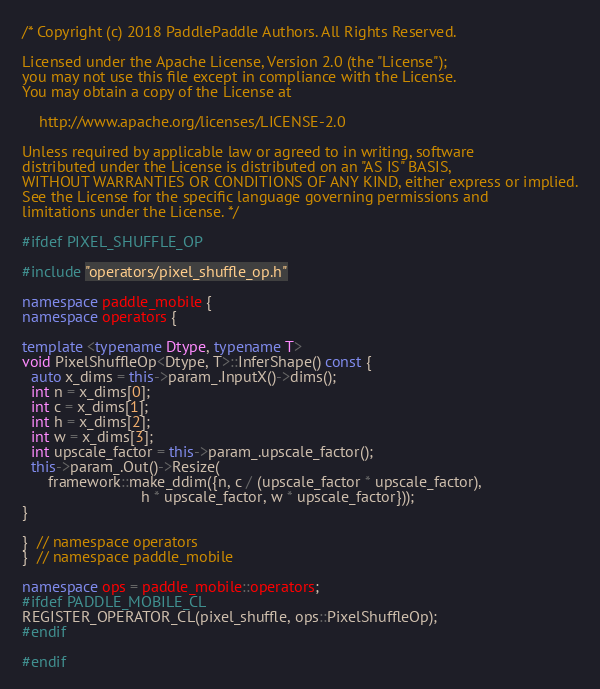Convert code to text. <code><loc_0><loc_0><loc_500><loc_500><_C++_>/* Copyright (c) 2018 PaddlePaddle Authors. All Rights Reserved.

Licensed under the Apache License, Version 2.0 (the "License");
you may not use this file except in compliance with the License.
You may obtain a copy of the License at

    http://www.apache.org/licenses/LICENSE-2.0

Unless required by applicable law or agreed to in writing, software
distributed under the License is distributed on an "AS IS" BASIS,
WITHOUT WARRANTIES OR CONDITIONS OF ANY KIND, either express or implied.
See the License for the specific language governing permissions and
limitations under the License. */

#ifdef PIXEL_SHUFFLE_OP

#include "operators/pixel_shuffle_op.h"

namespace paddle_mobile {
namespace operators {

template <typename Dtype, typename T>
void PixelShuffleOp<Dtype, T>::InferShape() const {
  auto x_dims = this->param_.InputX()->dims();
  int n = x_dims[0];
  int c = x_dims[1];
  int h = x_dims[2];
  int w = x_dims[3];
  int upscale_factor = this->param_.upscale_factor();
  this->param_.Out()->Resize(
      framework::make_ddim({n, c / (upscale_factor * upscale_factor),
                            h * upscale_factor, w * upscale_factor}));
}

}  // namespace operators
}  // namespace paddle_mobile

namespace ops = paddle_mobile::operators;
#ifdef PADDLE_MOBILE_CL
REGISTER_OPERATOR_CL(pixel_shuffle, ops::PixelShuffleOp);
#endif

#endif
</code> 